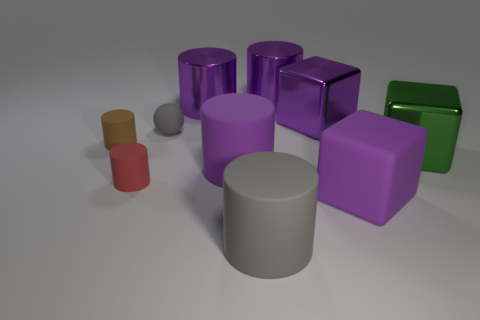Subtract all purple cylinders. How many were subtracted if there are1purple cylinders left? 2 Subtract all small rubber cylinders. How many cylinders are left? 4 Subtract all blue cylinders. How many purple cubes are left? 2 Subtract 1 cylinders. How many cylinders are left? 5 Subtract all purple cylinders. How many cylinders are left? 3 Add 6 small gray matte balls. How many small gray matte balls exist? 7 Subtract 0 brown blocks. How many objects are left? 10 Subtract all cylinders. How many objects are left? 4 Subtract all purple blocks. Subtract all purple spheres. How many blocks are left? 1 Subtract all small cyan shiny cubes. Subtract all big green things. How many objects are left? 9 